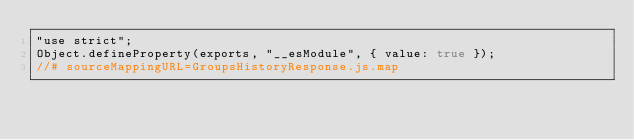<code> <loc_0><loc_0><loc_500><loc_500><_JavaScript_>"use strict";
Object.defineProperty(exports, "__esModule", { value: true });
//# sourceMappingURL=GroupsHistoryResponse.js.map</code> 